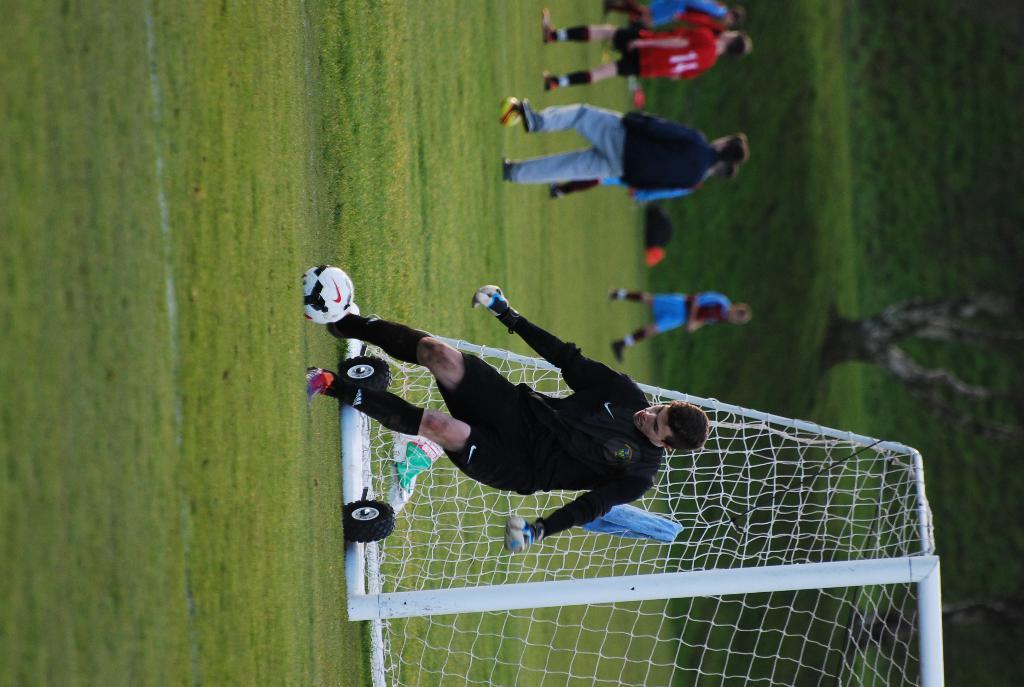What is the boy doing in the image? The boy is playing with a ball in the image. What is present in the image that might be used for catching or hitting the ball? There is a net in the image. What can be seen in the background of the image? There are people and greenery in the background of the image. What type of government is depicted in the image? There is no depiction of a government in the image; it features a boy playing with a ball and a net. Can you identify any fowl in the image? There are no fowl present in the image. 